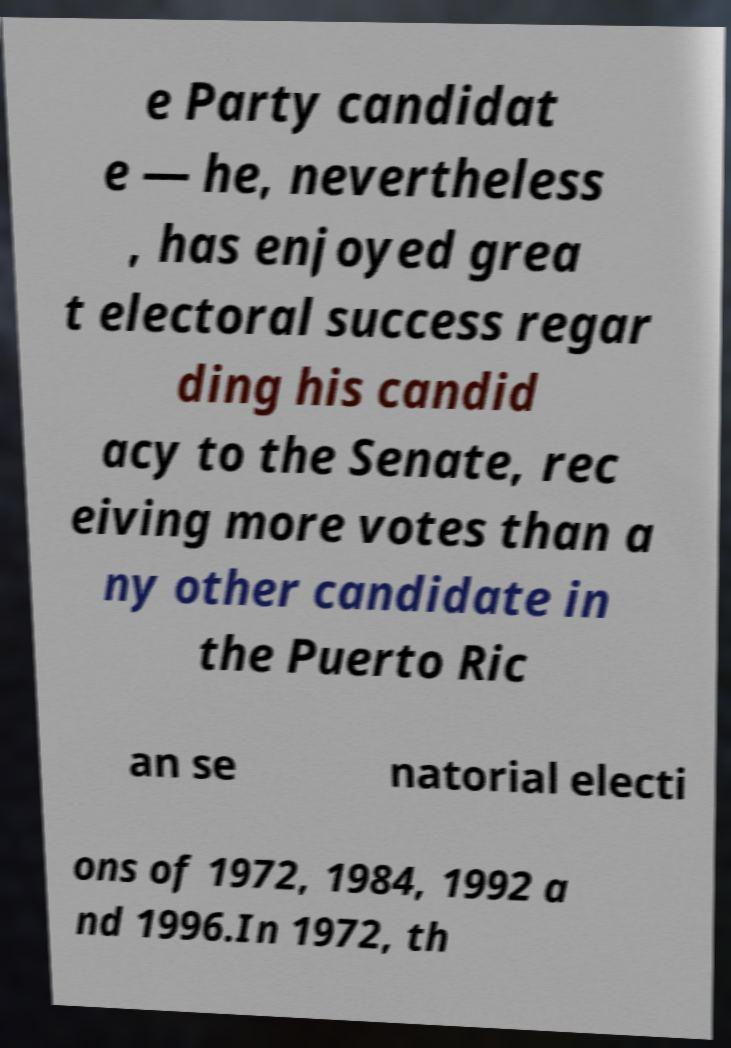Please read and relay the text visible in this image. What does it say? e Party candidat e — he, nevertheless , has enjoyed grea t electoral success regar ding his candid acy to the Senate, rec eiving more votes than a ny other candidate in the Puerto Ric an se natorial electi ons of 1972, 1984, 1992 a nd 1996.In 1972, th 